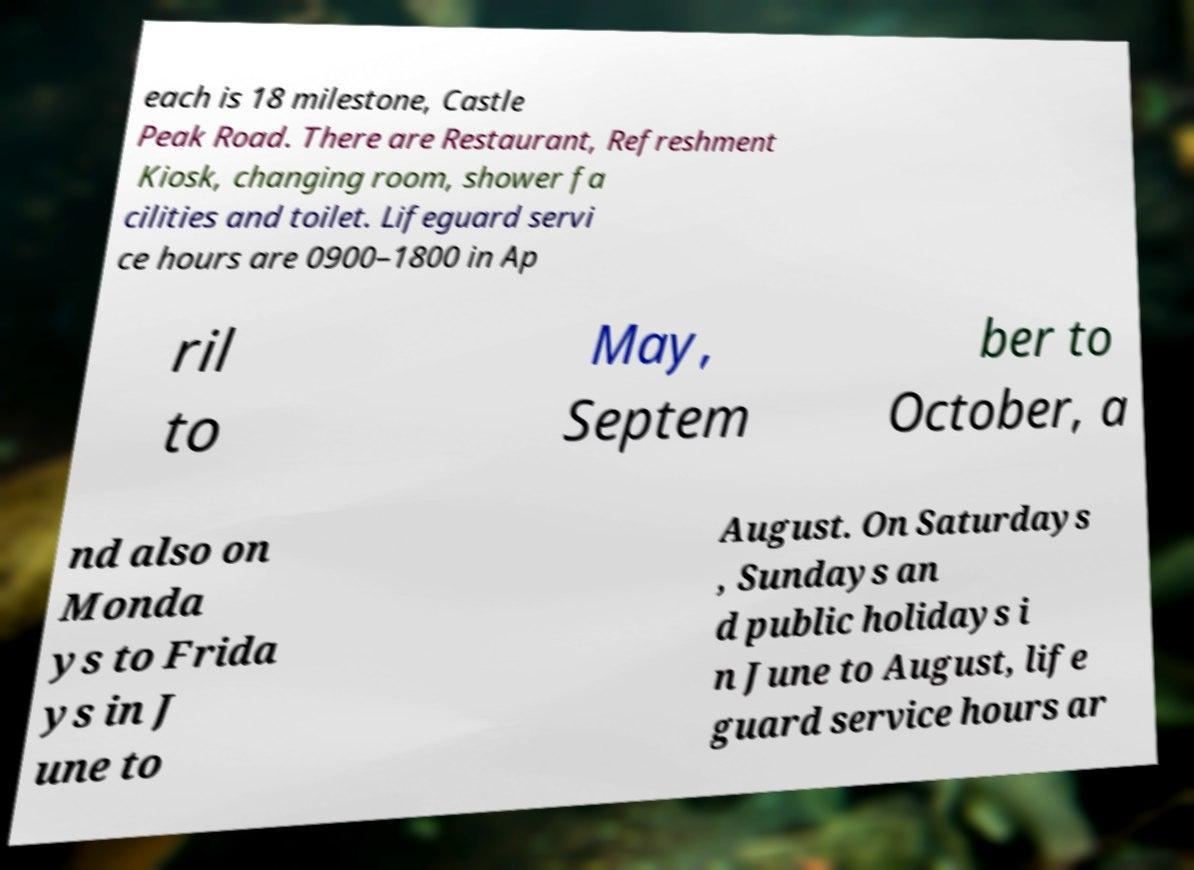There's text embedded in this image that I need extracted. Can you transcribe it verbatim? each is 18 milestone, Castle Peak Road. There are Restaurant, Refreshment Kiosk, changing room, shower fa cilities and toilet. Lifeguard servi ce hours are 0900–1800 in Ap ril to May, Septem ber to October, a nd also on Monda ys to Frida ys in J une to August. On Saturdays , Sundays an d public holidays i n June to August, life guard service hours ar 